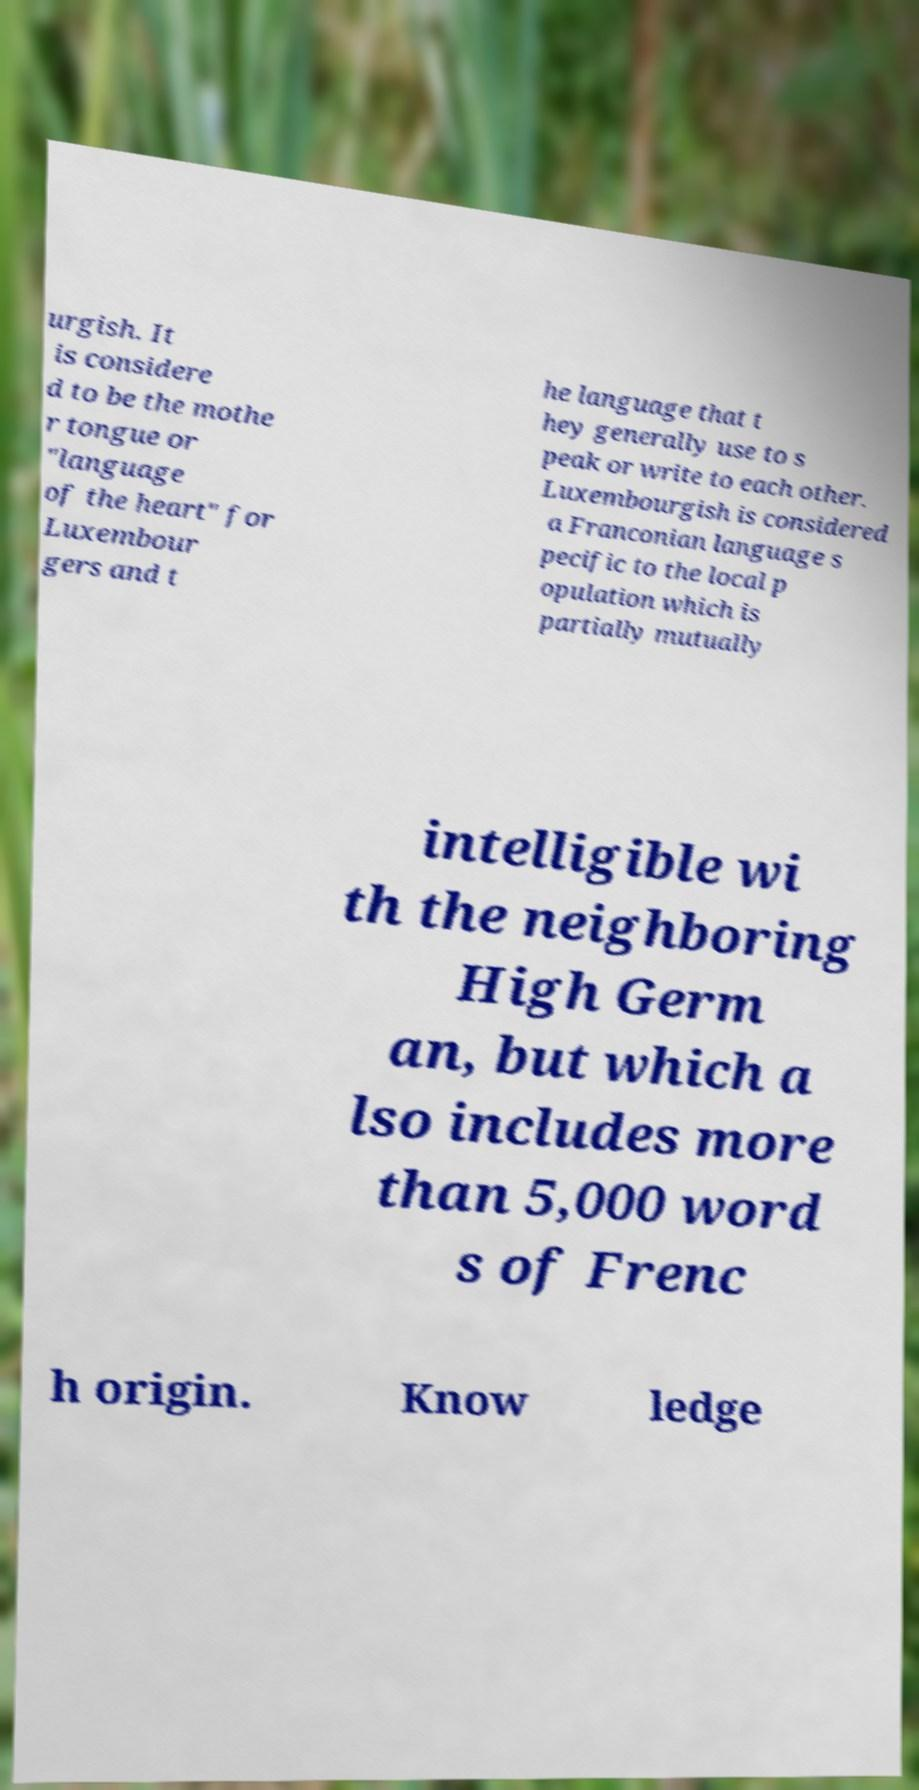Could you assist in decoding the text presented in this image and type it out clearly? urgish. It is considere d to be the mothe r tongue or "language of the heart" for Luxembour gers and t he language that t hey generally use to s peak or write to each other. Luxembourgish is considered a Franconian language s pecific to the local p opulation which is partially mutually intelligible wi th the neighboring High Germ an, but which a lso includes more than 5,000 word s of Frenc h origin. Know ledge 